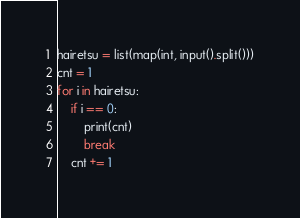Convert code to text. <code><loc_0><loc_0><loc_500><loc_500><_Python_>hairetsu = list(map(int, input().split()))
cnt = 1
for i in hairetsu:
    if i == 0:
        print(cnt)
        break
    cnt += 1</code> 